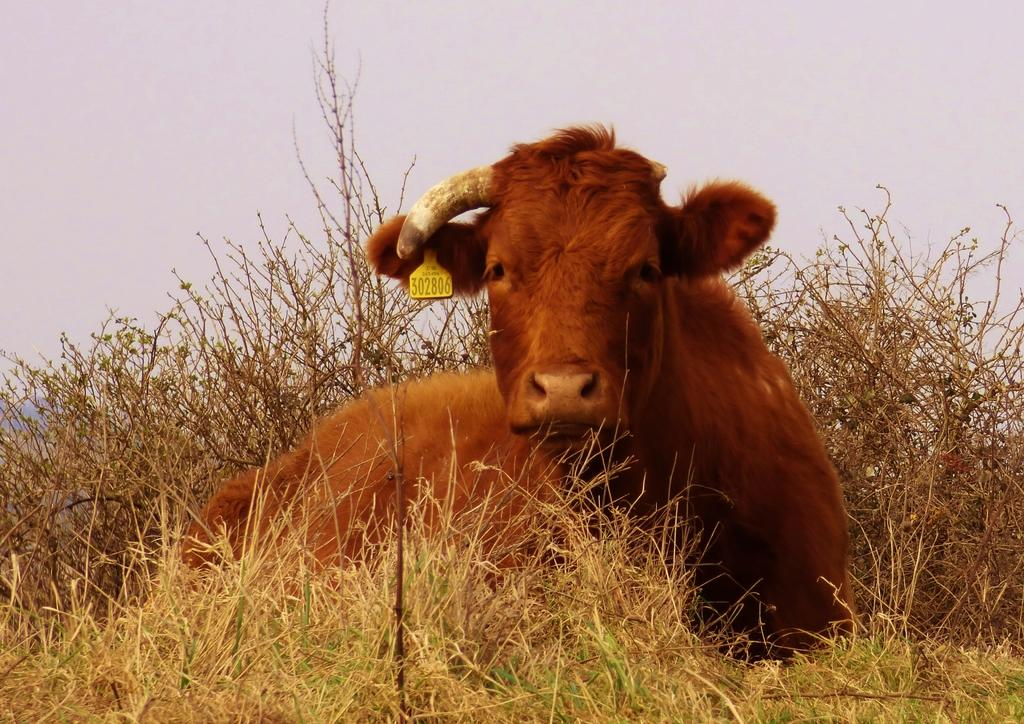What is the main subject of the image? There is an animal sitting in the image. Can you describe the color of the animal be described? The animal is in brown color. What can be seen at the top of the image? The sky is visible at the top of the image. What type of ground is present at the bottom of the image? There is grass at the bottom of the image. How much sugar is present in the vessel in the image? There is no vessel or sugar mentioned in the image; it features an animal sitting on grass with a visible sky. 